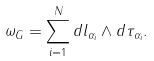<formula> <loc_0><loc_0><loc_500><loc_500>\omega _ { G } = \sum _ { i = 1 } ^ { N } d l _ { \alpha _ { i } } \wedge d \tau _ { \alpha _ { i } } .</formula> 